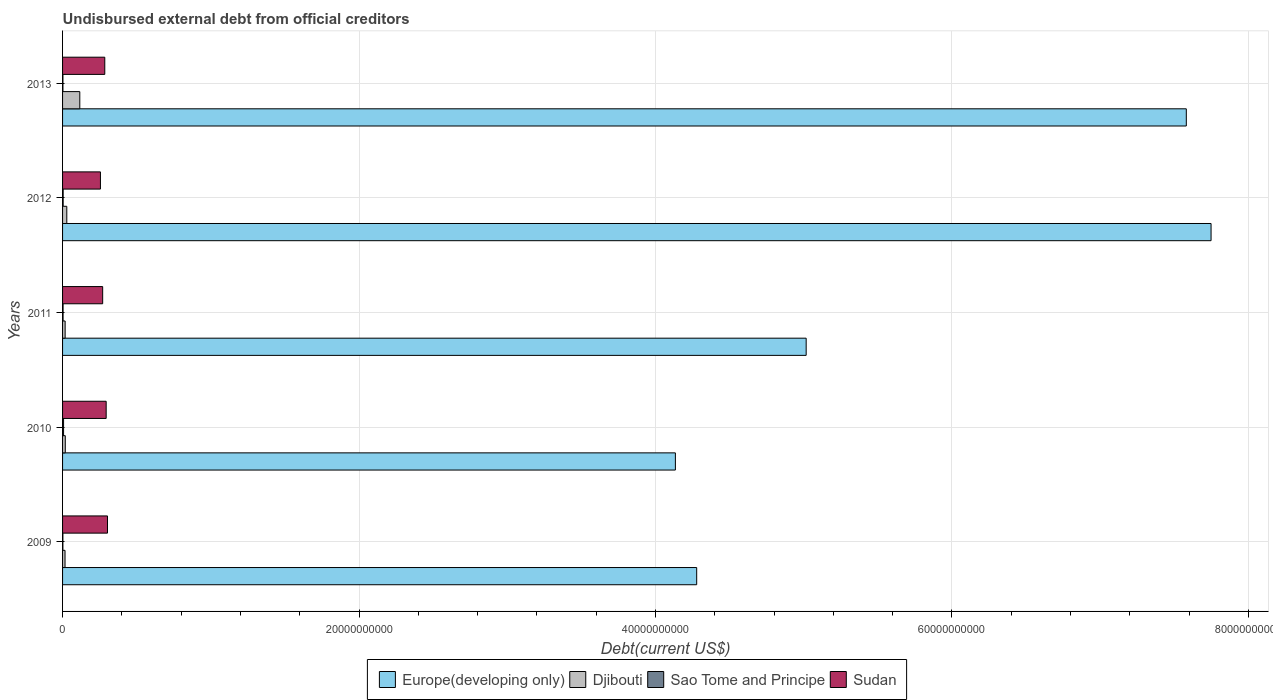How many different coloured bars are there?
Offer a very short reply. 4. Are the number of bars per tick equal to the number of legend labels?
Offer a terse response. Yes. How many bars are there on the 5th tick from the top?
Your answer should be compact. 4. How many bars are there on the 1st tick from the bottom?
Give a very brief answer. 4. What is the label of the 3rd group of bars from the top?
Offer a very short reply. 2011. In how many cases, is the number of bars for a given year not equal to the number of legend labels?
Offer a very short reply. 0. What is the total debt in Sao Tome and Principe in 2009?
Provide a succinct answer. 2.16e+07. Across all years, what is the maximum total debt in Djibouti?
Give a very brief answer. 1.16e+09. Across all years, what is the minimum total debt in Europe(developing only)?
Give a very brief answer. 4.13e+1. In which year was the total debt in Djibouti maximum?
Provide a succinct answer. 2013. What is the total total debt in Europe(developing only) in the graph?
Ensure brevity in your answer.  2.88e+11. What is the difference between the total debt in Sudan in 2011 and that in 2012?
Provide a succinct answer. 1.50e+08. What is the difference between the total debt in Sudan in 2009 and the total debt in Sao Tome and Principe in 2012?
Make the answer very short. 2.99e+09. What is the average total debt in Europe(developing only) per year?
Make the answer very short. 5.75e+1. In the year 2012, what is the difference between the total debt in Djibouti and total debt in Europe(developing only)?
Provide a succinct answer. -7.72e+1. What is the ratio of the total debt in Sao Tome and Principe in 2010 to that in 2011?
Give a very brief answer. 1.97. Is the total debt in Europe(developing only) in 2010 less than that in 2013?
Your answer should be compact. Yes. What is the difference between the highest and the second highest total debt in Sao Tome and Principe?
Your answer should be very brief. 2.80e+07. What is the difference between the highest and the lowest total debt in Europe(developing only)?
Keep it short and to the point. 3.61e+1. In how many years, is the total debt in Sudan greater than the average total debt in Sudan taken over all years?
Offer a terse response. 3. Is the sum of the total debt in Djibouti in 2010 and 2011 greater than the maximum total debt in Europe(developing only) across all years?
Offer a terse response. No. What does the 4th bar from the top in 2009 represents?
Ensure brevity in your answer.  Europe(developing only). What does the 4th bar from the bottom in 2013 represents?
Your answer should be compact. Sudan. Is it the case that in every year, the sum of the total debt in Europe(developing only) and total debt in Sudan is greater than the total debt in Sao Tome and Principe?
Your answer should be compact. Yes. Are all the bars in the graph horizontal?
Provide a succinct answer. Yes. How many years are there in the graph?
Offer a very short reply. 5. What is the difference between two consecutive major ticks on the X-axis?
Make the answer very short. 2.00e+1. Where does the legend appear in the graph?
Offer a terse response. Bottom center. How are the legend labels stacked?
Give a very brief answer. Horizontal. What is the title of the graph?
Offer a very short reply. Undisbursed external debt from official creditors. Does "Finland" appear as one of the legend labels in the graph?
Your answer should be compact. No. What is the label or title of the X-axis?
Ensure brevity in your answer.  Debt(current US$). What is the label or title of the Y-axis?
Keep it short and to the point. Years. What is the Debt(current US$) in Europe(developing only) in 2009?
Make the answer very short. 4.28e+1. What is the Debt(current US$) in Djibouti in 2009?
Ensure brevity in your answer.  1.66e+08. What is the Debt(current US$) in Sao Tome and Principe in 2009?
Provide a short and direct response. 2.16e+07. What is the Debt(current US$) of Sudan in 2009?
Make the answer very short. 3.03e+09. What is the Debt(current US$) of Europe(developing only) in 2010?
Keep it short and to the point. 4.13e+1. What is the Debt(current US$) of Djibouti in 2010?
Offer a terse response. 1.83e+08. What is the Debt(current US$) in Sao Tome and Principe in 2010?
Ensure brevity in your answer.  6.82e+07. What is the Debt(current US$) of Sudan in 2010?
Your answer should be very brief. 2.94e+09. What is the Debt(current US$) in Europe(developing only) in 2011?
Your response must be concise. 5.02e+1. What is the Debt(current US$) in Djibouti in 2011?
Ensure brevity in your answer.  1.73e+08. What is the Debt(current US$) in Sao Tome and Principe in 2011?
Offer a very short reply. 3.46e+07. What is the Debt(current US$) of Sudan in 2011?
Ensure brevity in your answer.  2.71e+09. What is the Debt(current US$) in Europe(developing only) in 2012?
Ensure brevity in your answer.  7.75e+1. What is the Debt(current US$) of Djibouti in 2012?
Your response must be concise. 2.85e+08. What is the Debt(current US$) in Sao Tome and Principe in 2012?
Your answer should be compact. 4.01e+07. What is the Debt(current US$) of Sudan in 2012?
Offer a very short reply. 2.55e+09. What is the Debt(current US$) in Europe(developing only) in 2013?
Make the answer very short. 7.58e+1. What is the Debt(current US$) in Djibouti in 2013?
Provide a succinct answer. 1.16e+09. What is the Debt(current US$) of Sao Tome and Principe in 2013?
Make the answer very short. 2.50e+07. What is the Debt(current US$) of Sudan in 2013?
Provide a short and direct response. 2.85e+09. Across all years, what is the maximum Debt(current US$) in Europe(developing only)?
Give a very brief answer. 7.75e+1. Across all years, what is the maximum Debt(current US$) of Djibouti?
Give a very brief answer. 1.16e+09. Across all years, what is the maximum Debt(current US$) of Sao Tome and Principe?
Offer a terse response. 6.82e+07. Across all years, what is the maximum Debt(current US$) of Sudan?
Your answer should be very brief. 3.03e+09. Across all years, what is the minimum Debt(current US$) in Europe(developing only)?
Offer a very short reply. 4.13e+1. Across all years, what is the minimum Debt(current US$) of Djibouti?
Your response must be concise. 1.66e+08. Across all years, what is the minimum Debt(current US$) in Sao Tome and Principe?
Give a very brief answer. 2.16e+07. Across all years, what is the minimum Debt(current US$) in Sudan?
Your answer should be compact. 2.55e+09. What is the total Debt(current US$) in Europe(developing only) in the graph?
Give a very brief answer. 2.88e+11. What is the total Debt(current US$) in Djibouti in the graph?
Make the answer very short. 1.97e+09. What is the total Debt(current US$) in Sao Tome and Principe in the graph?
Offer a terse response. 1.89e+08. What is the total Debt(current US$) of Sudan in the graph?
Ensure brevity in your answer.  1.41e+1. What is the difference between the Debt(current US$) in Europe(developing only) in 2009 and that in 2010?
Keep it short and to the point. 1.44e+09. What is the difference between the Debt(current US$) in Djibouti in 2009 and that in 2010?
Ensure brevity in your answer.  -1.66e+07. What is the difference between the Debt(current US$) in Sao Tome and Principe in 2009 and that in 2010?
Provide a succinct answer. -4.66e+07. What is the difference between the Debt(current US$) in Sudan in 2009 and that in 2010?
Your response must be concise. 8.92e+07. What is the difference between the Debt(current US$) in Europe(developing only) in 2009 and that in 2011?
Your answer should be very brief. -7.39e+09. What is the difference between the Debt(current US$) of Djibouti in 2009 and that in 2011?
Offer a very short reply. -7.25e+06. What is the difference between the Debt(current US$) in Sao Tome and Principe in 2009 and that in 2011?
Make the answer very short. -1.30e+07. What is the difference between the Debt(current US$) of Sudan in 2009 and that in 2011?
Ensure brevity in your answer.  3.26e+08. What is the difference between the Debt(current US$) of Europe(developing only) in 2009 and that in 2012?
Your answer should be compact. -3.47e+1. What is the difference between the Debt(current US$) in Djibouti in 2009 and that in 2012?
Keep it short and to the point. -1.19e+08. What is the difference between the Debt(current US$) in Sao Tome and Principe in 2009 and that in 2012?
Your answer should be compact. -1.86e+07. What is the difference between the Debt(current US$) in Sudan in 2009 and that in 2012?
Provide a succinct answer. 4.76e+08. What is the difference between the Debt(current US$) in Europe(developing only) in 2009 and that in 2013?
Offer a terse response. -3.30e+1. What is the difference between the Debt(current US$) of Djibouti in 2009 and that in 2013?
Offer a very short reply. -9.96e+08. What is the difference between the Debt(current US$) in Sao Tome and Principe in 2009 and that in 2013?
Provide a short and direct response. -3.41e+06. What is the difference between the Debt(current US$) in Sudan in 2009 and that in 2013?
Give a very brief answer. 1.83e+08. What is the difference between the Debt(current US$) in Europe(developing only) in 2010 and that in 2011?
Ensure brevity in your answer.  -8.82e+09. What is the difference between the Debt(current US$) in Djibouti in 2010 and that in 2011?
Provide a short and direct response. 9.31e+06. What is the difference between the Debt(current US$) in Sao Tome and Principe in 2010 and that in 2011?
Provide a short and direct response. 3.36e+07. What is the difference between the Debt(current US$) in Sudan in 2010 and that in 2011?
Provide a short and direct response. 2.37e+08. What is the difference between the Debt(current US$) in Europe(developing only) in 2010 and that in 2012?
Keep it short and to the point. -3.61e+1. What is the difference between the Debt(current US$) of Djibouti in 2010 and that in 2012?
Ensure brevity in your answer.  -1.02e+08. What is the difference between the Debt(current US$) in Sao Tome and Principe in 2010 and that in 2012?
Your answer should be compact. 2.80e+07. What is the difference between the Debt(current US$) of Sudan in 2010 and that in 2012?
Give a very brief answer. 3.87e+08. What is the difference between the Debt(current US$) in Europe(developing only) in 2010 and that in 2013?
Make the answer very short. -3.45e+1. What is the difference between the Debt(current US$) of Djibouti in 2010 and that in 2013?
Make the answer very short. -9.80e+08. What is the difference between the Debt(current US$) in Sao Tome and Principe in 2010 and that in 2013?
Provide a succinct answer. 4.32e+07. What is the difference between the Debt(current US$) in Sudan in 2010 and that in 2013?
Ensure brevity in your answer.  9.38e+07. What is the difference between the Debt(current US$) in Europe(developing only) in 2011 and that in 2012?
Your response must be concise. -2.73e+1. What is the difference between the Debt(current US$) of Djibouti in 2011 and that in 2012?
Your answer should be compact. -1.11e+08. What is the difference between the Debt(current US$) of Sao Tome and Principe in 2011 and that in 2012?
Offer a terse response. -5.58e+06. What is the difference between the Debt(current US$) of Sudan in 2011 and that in 2012?
Keep it short and to the point. 1.50e+08. What is the difference between the Debt(current US$) in Europe(developing only) in 2011 and that in 2013?
Your answer should be very brief. -2.56e+1. What is the difference between the Debt(current US$) of Djibouti in 2011 and that in 2013?
Your answer should be compact. -9.89e+08. What is the difference between the Debt(current US$) in Sao Tome and Principe in 2011 and that in 2013?
Provide a short and direct response. 9.61e+06. What is the difference between the Debt(current US$) of Sudan in 2011 and that in 2013?
Keep it short and to the point. -1.43e+08. What is the difference between the Debt(current US$) of Europe(developing only) in 2012 and that in 2013?
Keep it short and to the point. 1.67e+09. What is the difference between the Debt(current US$) of Djibouti in 2012 and that in 2013?
Ensure brevity in your answer.  -8.77e+08. What is the difference between the Debt(current US$) in Sao Tome and Principe in 2012 and that in 2013?
Ensure brevity in your answer.  1.52e+07. What is the difference between the Debt(current US$) in Sudan in 2012 and that in 2013?
Your answer should be very brief. -2.93e+08. What is the difference between the Debt(current US$) in Europe(developing only) in 2009 and the Debt(current US$) in Djibouti in 2010?
Make the answer very short. 4.26e+1. What is the difference between the Debt(current US$) in Europe(developing only) in 2009 and the Debt(current US$) in Sao Tome and Principe in 2010?
Provide a short and direct response. 4.27e+1. What is the difference between the Debt(current US$) in Europe(developing only) in 2009 and the Debt(current US$) in Sudan in 2010?
Keep it short and to the point. 3.98e+1. What is the difference between the Debt(current US$) of Djibouti in 2009 and the Debt(current US$) of Sao Tome and Principe in 2010?
Offer a very short reply. 9.81e+07. What is the difference between the Debt(current US$) of Djibouti in 2009 and the Debt(current US$) of Sudan in 2010?
Provide a succinct answer. -2.78e+09. What is the difference between the Debt(current US$) of Sao Tome and Principe in 2009 and the Debt(current US$) of Sudan in 2010?
Offer a very short reply. -2.92e+09. What is the difference between the Debt(current US$) of Europe(developing only) in 2009 and the Debt(current US$) of Djibouti in 2011?
Ensure brevity in your answer.  4.26e+1. What is the difference between the Debt(current US$) in Europe(developing only) in 2009 and the Debt(current US$) in Sao Tome and Principe in 2011?
Ensure brevity in your answer.  4.27e+1. What is the difference between the Debt(current US$) of Europe(developing only) in 2009 and the Debt(current US$) of Sudan in 2011?
Offer a terse response. 4.01e+1. What is the difference between the Debt(current US$) in Djibouti in 2009 and the Debt(current US$) in Sao Tome and Principe in 2011?
Provide a short and direct response. 1.32e+08. What is the difference between the Debt(current US$) of Djibouti in 2009 and the Debt(current US$) of Sudan in 2011?
Keep it short and to the point. -2.54e+09. What is the difference between the Debt(current US$) in Sao Tome and Principe in 2009 and the Debt(current US$) in Sudan in 2011?
Ensure brevity in your answer.  -2.68e+09. What is the difference between the Debt(current US$) of Europe(developing only) in 2009 and the Debt(current US$) of Djibouti in 2012?
Keep it short and to the point. 4.25e+1. What is the difference between the Debt(current US$) in Europe(developing only) in 2009 and the Debt(current US$) in Sao Tome and Principe in 2012?
Offer a very short reply. 4.27e+1. What is the difference between the Debt(current US$) in Europe(developing only) in 2009 and the Debt(current US$) in Sudan in 2012?
Offer a terse response. 4.02e+1. What is the difference between the Debt(current US$) of Djibouti in 2009 and the Debt(current US$) of Sao Tome and Principe in 2012?
Offer a terse response. 1.26e+08. What is the difference between the Debt(current US$) of Djibouti in 2009 and the Debt(current US$) of Sudan in 2012?
Provide a short and direct response. -2.39e+09. What is the difference between the Debt(current US$) in Sao Tome and Principe in 2009 and the Debt(current US$) in Sudan in 2012?
Your answer should be very brief. -2.53e+09. What is the difference between the Debt(current US$) of Europe(developing only) in 2009 and the Debt(current US$) of Djibouti in 2013?
Keep it short and to the point. 4.16e+1. What is the difference between the Debt(current US$) of Europe(developing only) in 2009 and the Debt(current US$) of Sao Tome and Principe in 2013?
Offer a very short reply. 4.28e+1. What is the difference between the Debt(current US$) in Europe(developing only) in 2009 and the Debt(current US$) in Sudan in 2013?
Your response must be concise. 3.99e+1. What is the difference between the Debt(current US$) of Djibouti in 2009 and the Debt(current US$) of Sao Tome and Principe in 2013?
Provide a succinct answer. 1.41e+08. What is the difference between the Debt(current US$) in Djibouti in 2009 and the Debt(current US$) in Sudan in 2013?
Keep it short and to the point. -2.68e+09. What is the difference between the Debt(current US$) of Sao Tome and Principe in 2009 and the Debt(current US$) of Sudan in 2013?
Make the answer very short. -2.83e+09. What is the difference between the Debt(current US$) in Europe(developing only) in 2010 and the Debt(current US$) in Djibouti in 2011?
Provide a succinct answer. 4.12e+1. What is the difference between the Debt(current US$) in Europe(developing only) in 2010 and the Debt(current US$) in Sao Tome and Principe in 2011?
Keep it short and to the point. 4.13e+1. What is the difference between the Debt(current US$) of Europe(developing only) in 2010 and the Debt(current US$) of Sudan in 2011?
Offer a terse response. 3.86e+1. What is the difference between the Debt(current US$) in Djibouti in 2010 and the Debt(current US$) in Sao Tome and Principe in 2011?
Provide a succinct answer. 1.48e+08. What is the difference between the Debt(current US$) of Djibouti in 2010 and the Debt(current US$) of Sudan in 2011?
Offer a terse response. -2.52e+09. What is the difference between the Debt(current US$) of Sao Tome and Principe in 2010 and the Debt(current US$) of Sudan in 2011?
Ensure brevity in your answer.  -2.64e+09. What is the difference between the Debt(current US$) of Europe(developing only) in 2010 and the Debt(current US$) of Djibouti in 2012?
Provide a short and direct response. 4.11e+1. What is the difference between the Debt(current US$) of Europe(developing only) in 2010 and the Debt(current US$) of Sao Tome and Principe in 2012?
Provide a succinct answer. 4.13e+1. What is the difference between the Debt(current US$) of Europe(developing only) in 2010 and the Debt(current US$) of Sudan in 2012?
Provide a succinct answer. 3.88e+1. What is the difference between the Debt(current US$) in Djibouti in 2010 and the Debt(current US$) in Sao Tome and Principe in 2012?
Your response must be concise. 1.43e+08. What is the difference between the Debt(current US$) of Djibouti in 2010 and the Debt(current US$) of Sudan in 2012?
Offer a terse response. -2.37e+09. What is the difference between the Debt(current US$) in Sao Tome and Principe in 2010 and the Debt(current US$) in Sudan in 2012?
Ensure brevity in your answer.  -2.49e+09. What is the difference between the Debt(current US$) of Europe(developing only) in 2010 and the Debt(current US$) of Djibouti in 2013?
Your response must be concise. 4.02e+1. What is the difference between the Debt(current US$) of Europe(developing only) in 2010 and the Debt(current US$) of Sao Tome and Principe in 2013?
Offer a very short reply. 4.13e+1. What is the difference between the Debt(current US$) of Europe(developing only) in 2010 and the Debt(current US$) of Sudan in 2013?
Your answer should be compact. 3.85e+1. What is the difference between the Debt(current US$) of Djibouti in 2010 and the Debt(current US$) of Sao Tome and Principe in 2013?
Give a very brief answer. 1.58e+08. What is the difference between the Debt(current US$) in Djibouti in 2010 and the Debt(current US$) in Sudan in 2013?
Keep it short and to the point. -2.67e+09. What is the difference between the Debt(current US$) in Sao Tome and Principe in 2010 and the Debt(current US$) in Sudan in 2013?
Offer a terse response. -2.78e+09. What is the difference between the Debt(current US$) of Europe(developing only) in 2011 and the Debt(current US$) of Djibouti in 2012?
Ensure brevity in your answer.  4.99e+1. What is the difference between the Debt(current US$) of Europe(developing only) in 2011 and the Debt(current US$) of Sao Tome and Principe in 2012?
Provide a short and direct response. 5.01e+1. What is the difference between the Debt(current US$) of Europe(developing only) in 2011 and the Debt(current US$) of Sudan in 2012?
Keep it short and to the point. 4.76e+1. What is the difference between the Debt(current US$) of Djibouti in 2011 and the Debt(current US$) of Sao Tome and Principe in 2012?
Give a very brief answer. 1.33e+08. What is the difference between the Debt(current US$) in Djibouti in 2011 and the Debt(current US$) in Sudan in 2012?
Provide a short and direct response. -2.38e+09. What is the difference between the Debt(current US$) of Sao Tome and Principe in 2011 and the Debt(current US$) of Sudan in 2012?
Your answer should be compact. -2.52e+09. What is the difference between the Debt(current US$) in Europe(developing only) in 2011 and the Debt(current US$) in Djibouti in 2013?
Make the answer very short. 4.90e+1. What is the difference between the Debt(current US$) in Europe(developing only) in 2011 and the Debt(current US$) in Sao Tome and Principe in 2013?
Offer a terse response. 5.01e+1. What is the difference between the Debt(current US$) in Europe(developing only) in 2011 and the Debt(current US$) in Sudan in 2013?
Keep it short and to the point. 4.73e+1. What is the difference between the Debt(current US$) of Djibouti in 2011 and the Debt(current US$) of Sao Tome and Principe in 2013?
Offer a very short reply. 1.49e+08. What is the difference between the Debt(current US$) in Djibouti in 2011 and the Debt(current US$) in Sudan in 2013?
Give a very brief answer. -2.67e+09. What is the difference between the Debt(current US$) of Sao Tome and Principe in 2011 and the Debt(current US$) of Sudan in 2013?
Your answer should be compact. -2.81e+09. What is the difference between the Debt(current US$) in Europe(developing only) in 2012 and the Debt(current US$) in Djibouti in 2013?
Provide a succinct answer. 7.63e+1. What is the difference between the Debt(current US$) in Europe(developing only) in 2012 and the Debt(current US$) in Sao Tome and Principe in 2013?
Your answer should be compact. 7.75e+1. What is the difference between the Debt(current US$) in Europe(developing only) in 2012 and the Debt(current US$) in Sudan in 2013?
Make the answer very short. 7.46e+1. What is the difference between the Debt(current US$) of Djibouti in 2012 and the Debt(current US$) of Sao Tome and Principe in 2013?
Offer a very short reply. 2.60e+08. What is the difference between the Debt(current US$) of Djibouti in 2012 and the Debt(current US$) of Sudan in 2013?
Your answer should be compact. -2.56e+09. What is the difference between the Debt(current US$) in Sao Tome and Principe in 2012 and the Debt(current US$) in Sudan in 2013?
Provide a succinct answer. -2.81e+09. What is the average Debt(current US$) of Europe(developing only) per year?
Ensure brevity in your answer.  5.75e+1. What is the average Debt(current US$) of Djibouti per year?
Give a very brief answer. 3.94e+08. What is the average Debt(current US$) in Sao Tome and Principe per year?
Make the answer very short. 3.79e+07. What is the average Debt(current US$) of Sudan per year?
Give a very brief answer. 2.82e+09. In the year 2009, what is the difference between the Debt(current US$) of Europe(developing only) and Debt(current US$) of Djibouti?
Provide a succinct answer. 4.26e+1. In the year 2009, what is the difference between the Debt(current US$) in Europe(developing only) and Debt(current US$) in Sao Tome and Principe?
Make the answer very short. 4.28e+1. In the year 2009, what is the difference between the Debt(current US$) in Europe(developing only) and Debt(current US$) in Sudan?
Make the answer very short. 3.97e+1. In the year 2009, what is the difference between the Debt(current US$) in Djibouti and Debt(current US$) in Sao Tome and Principe?
Your response must be concise. 1.45e+08. In the year 2009, what is the difference between the Debt(current US$) in Djibouti and Debt(current US$) in Sudan?
Provide a short and direct response. -2.86e+09. In the year 2009, what is the difference between the Debt(current US$) of Sao Tome and Principe and Debt(current US$) of Sudan?
Your answer should be compact. -3.01e+09. In the year 2010, what is the difference between the Debt(current US$) of Europe(developing only) and Debt(current US$) of Djibouti?
Make the answer very short. 4.12e+1. In the year 2010, what is the difference between the Debt(current US$) of Europe(developing only) and Debt(current US$) of Sao Tome and Principe?
Keep it short and to the point. 4.13e+1. In the year 2010, what is the difference between the Debt(current US$) in Europe(developing only) and Debt(current US$) in Sudan?
Keep it short and to the point. 3.84e+1. In the year 2010, what is the difference between the Debt(current US$) of Djibouti and Debt(current US$) of Sao Tome and Principe?
Provide a short and direct response. 1.15e+08. In the year 2010, what is the difference between the Debt(current US$) of Djibouti and Debt(current US$) of Sudan?
Your answer should be compact. -2.76e+09. In the year 2010, what is the difference between the Debt(current US$) in Sao Tome and Principe and Debt(current US$) in Sudan?
Provide a short and direct response. -2.87e+09. In the year 2011, what is the difference between the Debt(current US$) of Europe(developing only) and Debt(current US$) of Djibouti?
Ensure brevity in your answer.  5.00e+1. In the year 2011, what is the difference between the Debt(current US$) of Europe(developing only) and Debt(current US$) of Sao Tome and Principe?
Make the answer very short. 5.01e+1. In the year 2011, what is the difference between the Debt(current US$) of Europe(developing only) and Debt(current US$) of Sudan?
Give a very brief answer. 4.75e+1. In the year 2011, what is the difference between the Debt(current US$) of Djibouti and Debt(current US$) of Sao Tome and Principe?
Your response must be concise. 1.39e+08. In the year 2011, what is the difference between the Debt(current US$) in Djibouti and Debt(current US$) in Sudan?
Your answer should be very brief. -2.53e+09. In the year 2011, what is the difference between the Debt(current US$) of Sao Tome and Principe and Debt(current US$) of Sudan?
Your answer should be compact. -2.67e+09. In the year 2012, what is the difference between the Debt(current US$) of Europe(developing only) and Debt(current US$) of Djibouti?
Your response must be concise. 7.72e+1. In the year 2012, what is the difference between the Debt(current US$) of Europe(developing only) and Debt(current US$) of Sao Tome and Principe?
Provide a succinct answer. 7.74e+1. In the year 2012, what is the difference between the Debt(current US$) in Europe(developing only) and Debt(current US$) in Sudan?
Offer a very short reply. 7.49e+1. In the year 2012, what is the difference between the Debt(current US$) in Djibouti and Debt(current US$) in Sao Tome and Principe?
Your response must be concise. 2.45e+08. In the year 2012, what is the difference between the Debt(current US$) of Djibouti and Debt(current US$) of Sudan?
Your answer should be very brief. -2.27e+09. In the year 2012, what is the difference between the Debt(current US$) of Sao Tome and Principe and Debt(current US$) of Sudan?
Ensure brevity in your answer.  -2.51e+09. In the year 2013, what is the difference between the Debt(current US$) of Europe(developing only) and Debt(current US$) of Djibouti?
Ensure brevity in your answer.  7.46e+1. In the year 2013, what is the difference between the Debt(current US$) of Europe(developing only) and Debt(current US$) of Sao Tome and Principe?
Give a very brief answer. 7.58e+1. In the year 2013, what is the difference between the Debt(current US$) of Europe(developing only) and Debt(current US$) of Sudan?
Ensure brevity in your answer.  7.30e+1. In the year 2013, what is the difference between the Debt(current US$) in Djibouti and Debt(current US$) in Sao Tome and Principe?
Give a very brief answer. 1.14e+09. In the year 2013, what is the difference between the Debt(current US$) of Djibouti and Debt(current US$) of Sudan?
Give a very brief answer. -1.69e+09. In the year 2013, what is the difference between the Debt(current US$) of Sao Tome and Principe and Debt(current US$) of Sudan?
Your answer should be compact. -2.82e+09. What is the ratio of the Debt(current US$) of Europe(developing only) in 2009 to that in 2010?
Offer a very short reply. 1.03. What is the ratio of the Debt(current US$) of Djibouti in 2009 to that in 2010?
Offer a very short reply. 0.91. What is the ratio of the Debt(current US$) of Sao Tome and Principe in 2009 to that in 2010?
Your answer should be compact. 0.32. What is the ratio of the Debt(current US$) of Sudan in 2009 to that in 2010?
Your answer should be very brief. 1.03. What is the ratio of the Debt(current US$) in Europe(developing only) in 2009 to that in 2011?
Offer a terse response. 0.85. What is the ratio of the Debt(current US$) of Djibouti in 2009 to that in 2011?
Your answer should be compact. 0.96. What is the ratio of the Debt(current US$) in Sao Tome and Principe in 2009 to that in 2011?
Ensure brevity in your answer.  0.62. What is the ratio of the Debt(current US$) in Sudan in 2009 to that in 2011?
Provide a succinct answer. 1.12. What is the ratio of the Debt(current US$) of Europe(developing only) in 2009 to that in 2012?
Offer a very short reply. 0.55. What is the ratio of the Debt(current US$) in Djibouti in 2009 to that in 2012?
Keep it short and to the point. 0.58. What is the ratio of the Debt(current US$) in Sao Tome and Principe in 2009 to that in 2012?
Provide a succinct answer. 0.54. What is the ratio of the Debt(current US$) of Sudan in 2009 to that in 2012?
Ensure brevity in your answer.  1.19. What is the ratio of the Debt(current US$) in Europe(developing only) in 2009 to that in 2013?
Give a very brief answer. 0.56. What is the ratio of the Debt(current US$) in Djibouti in 2009 to that in 2013?
Provide a succinct answer. 0.14. What is the ratio of the Debt(current US$) in Sao Tome and Principe in 2009 to that in 2013?
Provide a short and direct response. 0.86. What is the ratio of the Debt(current US$) of Sudan in 2009 to that in 2013?
Your answer should be very brief. 1.06. What is the ratio of the Debt(current US$) in Europe(developing only) in 2010 to that in 2011?
Keep it short and to the point. 0.82. What is the ratio of the Debt(current US$) in Djibouti in 2010 to that in 2011?
Your answer should be compact. 1.05. What is the ratio of the Debt(current US$) of Sao Tome and Principe in 2010 to that in 2011?
Keep it short and to the point. 1.97. What is the ratio of the Debt(current US$) of Sudan in 2010 to that in 2011?
Your answer should be compact. 1.09. What is the ratio of the Debt(current US$) of Europe(developing only) in 2010 to that in 2012?
Your response must be concise. 0.53. What is the ratio of the Debt(current US$) of Djibouti in 2010 to that in 2012?
Offer a very short reply. 0.64. What is the ratio of the Debt(current US$) of Sao Tome and Principe in 2010 to that in 2012?
Provide a succinct answer. 1.7. What is the ratio of the Debt(current US$) in Sudan in 2010 to that in 2012?
Provide a succinct answer. 1.15. What is the ratio of the Debt(current US$) in Europe(developing only) in 2010 to that in 2013?
Your response must be concise. 0.55. What is the ratio of the Debt(current US$) in Djibouti in 2010 to that in 2013?
Your answer should be compact. 0.16. What is the ratio of the Debt(current US$) in Sao Tome and Principe in 2010 to that in 2013?
Offer a very short reply. 2.73. What is the ratio of the Debt(current US$) in Sudan in 2010 to that in 2013?
Your response must be concise. 1.03. What is the ratio of the Debt(current US$) of Europe(developing only) in 2011 to that in 2012?
Ensure brevity in your answer.  0.65. What is the ratio of the Debt(current US$) of Djibouti in 2011 to that in 2012?
Provide a succinct answer. 0.61. What is the ratio of the Debt(current US$) in Sao Tome and Principe in 2011 to that in 2012?
Offer a very short reply. 0.86. What is the ratio of the Debt(current US$) of Sudan in 2011 to that in 2012?
Provide a succinct answer. 1.06. What is the ratio of the Debt(current US$) of Europe(developing only) in 2011 to that in 2013?
Your answer should be very brief. 0.66. What is the ratio of the Debt(current US$) of Djibouti in 2011 to that in 2013?
Ensure brevity in your answer.  0.15. What is the ratio of the Debt(current US$) in Sao Tome and Principe in 2011 to that in 2013?
Give a very brief answer. 1.38. What is the ratio of the Debt(current US$) of Sudan in 2011 to that in 2013?
Your response must be concise. 0.95. What is the ratio of the Debt(current US$) of Europe(developing only) in 2012 to that in 2013?
Keep it short and to the point. 1.02. What is the ratio of the Debt(current US$) of Djibouti in 2012 to that in 2013?
Make the answer very short. 0.25. What is the ratio of the Debt(current US$) in Sao Tome and Principe in 2012 to that in 2013?
Provide a succinct answer. 1.61. What is the ratio of the Debt(current US$) of Sudan in 2012 to that in 2013?
Your response must be concise. 0.9. What is the difference between the highest and the second highest Debt(current US$) of Europe(developing only)?
Your response must be concise. 1.67e+09. What is the difference between the highest and the second highest Debt(current US$) of Djibouti?
Make the answer very short. 8.77e+08. What is the difference between the highest and the second highest Debt(current US$) in Sao Tome and Principe?
Your response must be concise. 2.80e+07. What is the difference between the highest and the second highest Debt(current US$) in Sudan?
Provide a succinct answer. 8.92e+07. What is the difference between the highest and the lowest Debt(current US$) of Europe(developing only)?
Offer a very short reply. 3.61e+1. What is the difference between the highest and the lowest Debt(current US$) in Djibouti?
Offer a terse response. 9.96e+08. What is the difference between the highest and the lowest Debt(current US$) in Sao Tome and Principe?
Provide a succinct answer. 4.66e+07. What is the difference between the highest and the lowest Debt(current US$) of Sudan?
Your answer should be very brief. 4.76e+08. 